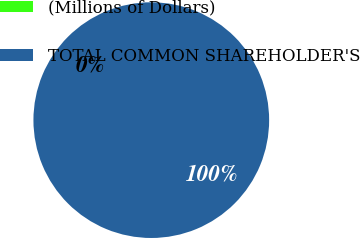Convert chart. <chart><loc_0><loc_0><loc_500><loc_500><pie_chart><fcel>(Millions of Dollars)<fcel>TOTAL COMMON SHAREHOLDER'S<nl><fcel>0.0%<fcel>100.0%<nl></chart> 